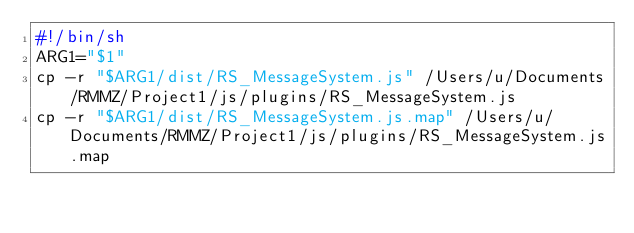Convert code to text. <code><loc_0><loc_0><loc_500><loc_500><_Bash_>#!/bin/sh
ARG1="$1"
cp -r "$ARG1/dist/RS_MessageSystem.js" /Users/u/Documents/RMMZ/Project1/js/plugins/RS_MessageSystem.js
cp -r "$ARG1/dist/RS_MessageSystem.js.map" /Users/u/Documents/RMMZ/Project1/js/plugins/RS_MessageSystem.js.map</code> 